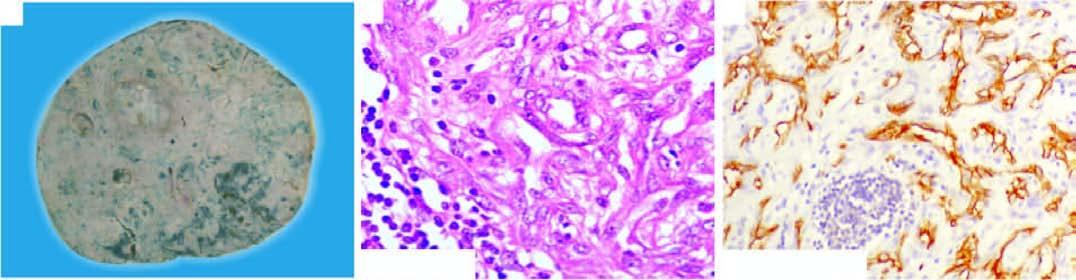do the tumour cells show proliferation of moderately pleomorphic anaplastic cells?
Answer the question using a single word or phrase. Yes 